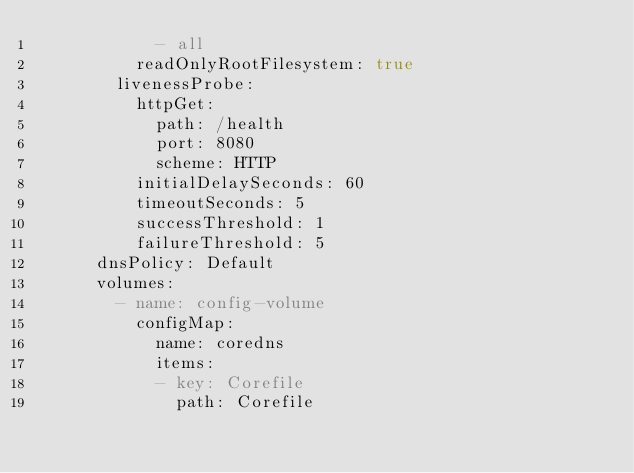<code> <loc_0><loc_0><loc_500><loc_500><_YAML_>            - all
          readOnlyRootFilesystem: true
        livenessProbe:
          httpGet:
            path: /health
            port: 8080
            scheme: HTTP
          initialDelaySeconds: 60
          timeoutSeconds: 5
          successThreshold: 1
          failureThreshold: 5
      dnsPolicy: Default
      volumes:
        - name: config-volume
          configMap:
            name: coredns
            items:
            - key: Corefile
              path: Corefile
</code> 